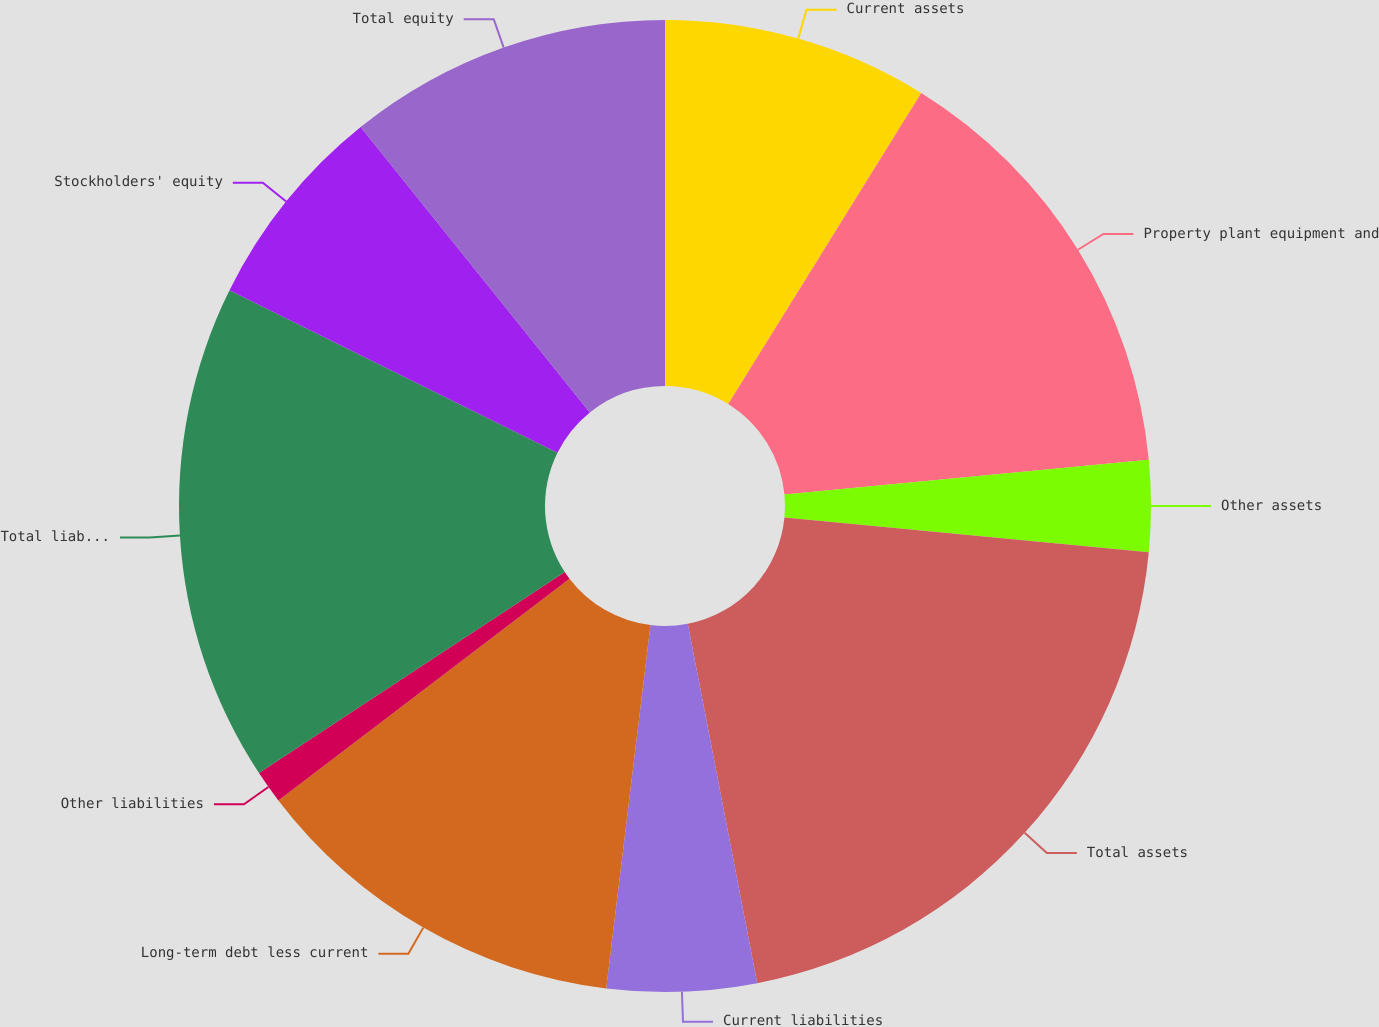Convert chart. <chart><loc_0><loc_0><loc_500><loc_500><pie_chart><fcel>Current assets<fcel>Property plant equipment and<fcel>Other assets<fcel>Total assets<fcel>Current liabilities<fcel>Long-term debt less current<fcel>Other liabilities<fcel>Total liabilities<fcel>Stockholders' equity<fcel>Total equity<nl><fcel>8.84%<fcel>14.64%<fcel>3.04%<fcel>20.44%<fcel>4.97%<fcel>12.71%<fcel>1.1%<fcel>16.58%<fcel>6.91%<fcel>10.77%<nl></chart> 